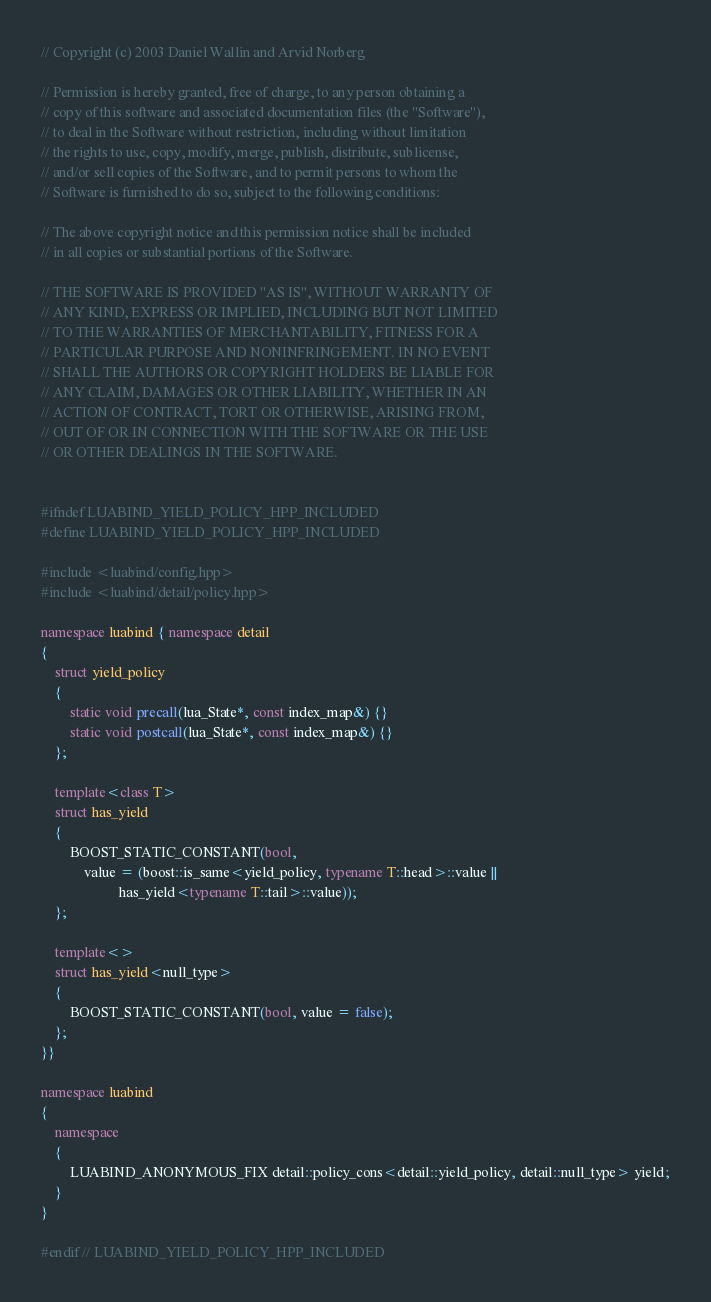<code> <loc_0><loc_0><loc_500><loc_500><_C++_>// Copyright (c) 2003 Daniel Wallin and Arvid Norberg

// Permission is hereby granted, free of charge, to any person obtaining a
// copy of this software and associated documentation files (the "Software"),
// to deal in the Software without restriction, including without limitation
// the rights to use, copy, modify, merge, publish, distribute, sublicense,
// and/or sell copies of the Software, and to permit persons to whom the
// Software is furnished to do so, subject to the following conditions:

// The above copyright notice and this permission notice shall be included
// in all copies or substantial portions of the Software.

// THE SOFTWARE IS PROVIDED "AS IS", WITHOUT WARRANTY OF
// ANY KIND, EXPRESS OR IMPLIED, INCLUDING BUT NOT LIMITED
// TO THE WARRANTIES OF MERCHANTABILITY, FITNESS FOR A
// PARTICULAR PURPOSE AND NONINFRINGEMENT. IN NO EVENT
// SHALL THE AUTHORS OR COPYRIGHT HOLDERS BE LIABLE FOR
// ANY CLAIM, DAMAGES OR OTHER LIABILITY, WHETHER IN AN
// ACTION OF CONTRACT, TORT OR OTHERWISE, ARISING FROM,
// OUT OF OR IN CONNECTION WITH THE SOFTWARE OR THE USE
// OR OTHER DEALINGS IN THE SOFTWARE.


#ifndef LUABIND_YIELD_POLICY_HPP_INCLUDED
#define LUABIND_YIELD_POLICY_HPP_INCLUDED

#include <luabind/config.hpp>
#include <luabind/detail/policy.hpp>

namespace luabind { namespace detail 
{
	struct yield_policy
	{
		static void precall(lua_State*, const index_map&) {}
		static void postcall(lua_State*, const index_map&) {}
	};

	template<class T>
	struct has_yield
	{
		BOOST_STATIC_CONSTANT(bool,
			value = (boost::is_same<yield_policy, typename T::head>::value ||
					  has_yield<typename T::tail>::value));
	};

	template<>
	struct has_yield<null_type>
	{
		BOOST_STATIC_CONSTANT(bool, value = false);
	};
}}

namespace luabind
{
	namespace 
	{
		LUABIND_ANONYMOUS_FIX detail::policy_cons<detail::yield_policy, detail::null_type> yield;
	}
}

#endif // LUABIND_YIELD_POLICY_HPP_INCLUDED

</code> 